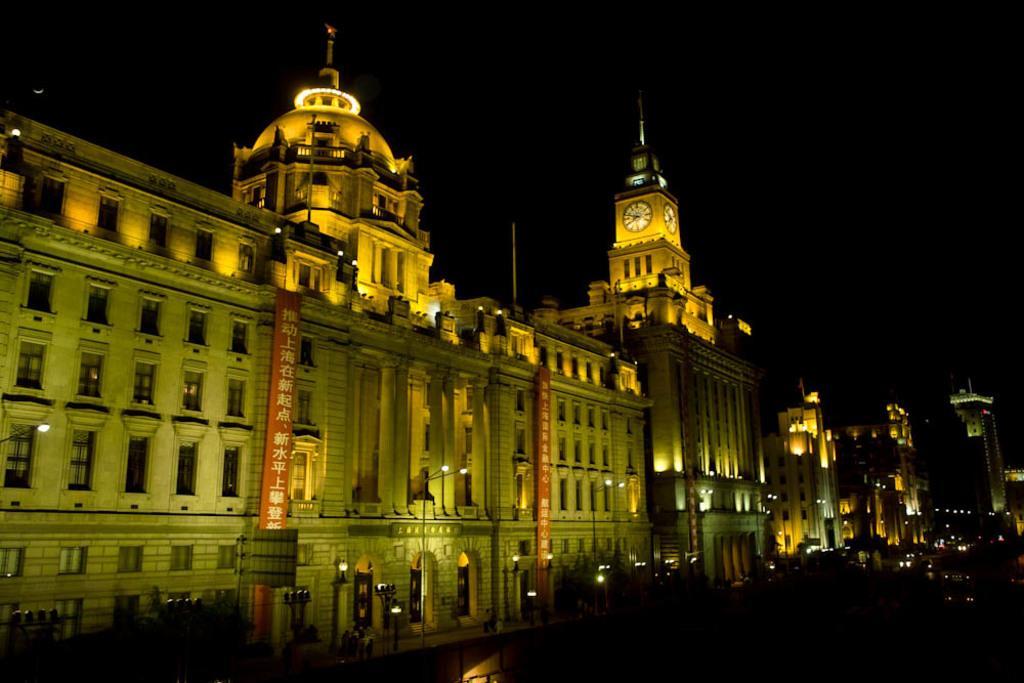Can you describe this image briefly? Here in this picture we can see number of buildings with windows and doors present over a place and we can see banners present on buildings and we can also see a clock present and we can also see lamp posts present. 